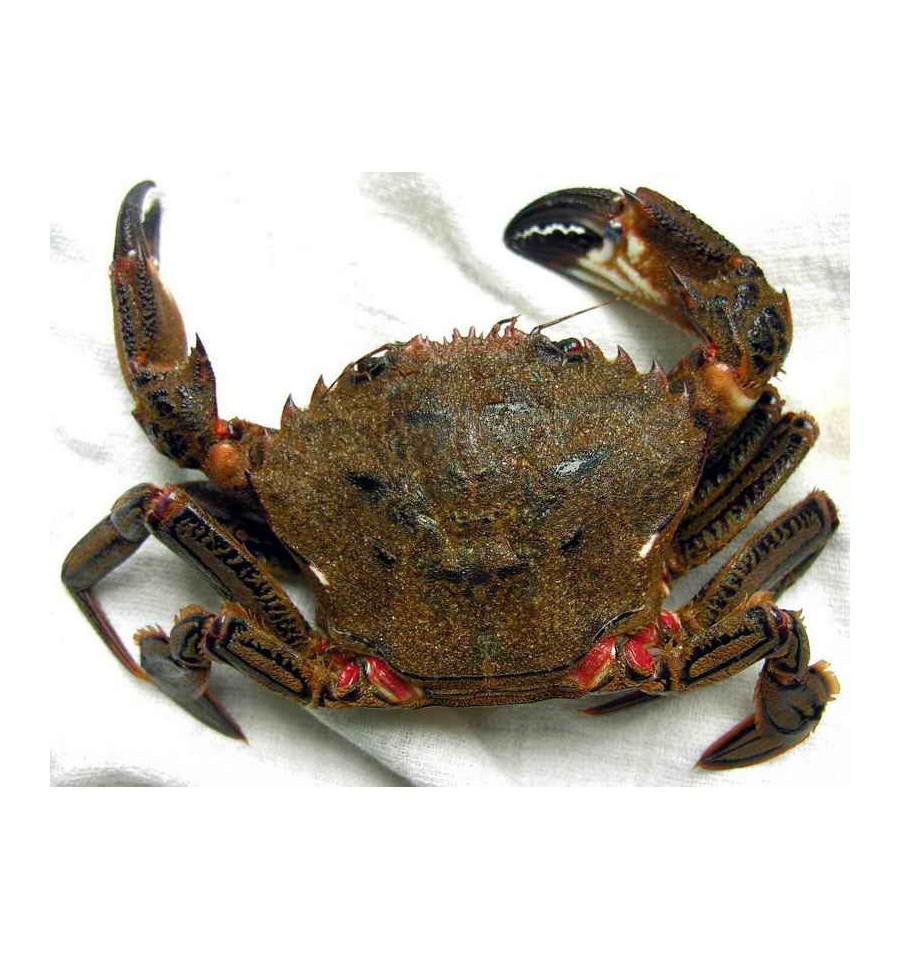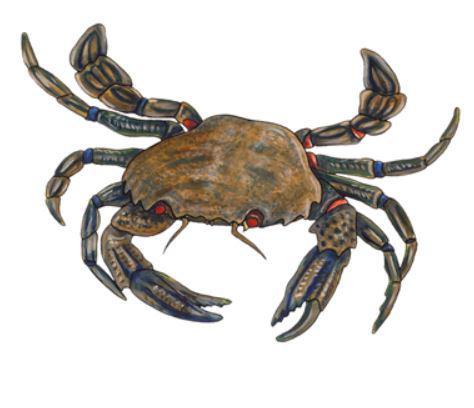The first image is the image on the left, the second image is the image on the right. Given the left and right images, does the statement "The left and right image contains the same number of crabs with at least one with blue claws." hold true? Answer yes or no. Yes. 